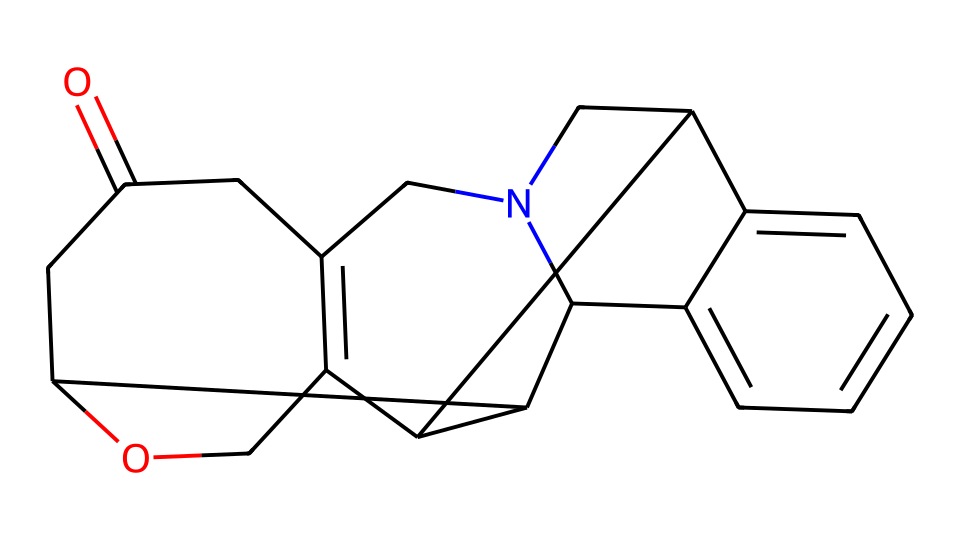What is the molecular formula of strychnine? To determine the molecular formula, we analyze the structure represented by the SMILES notation, counting the atoms of each element. The structure has 21 carbons, 24 hydrogens, 2 nitrogens, and 3 oxygens. Therefore, the molecular formula is C21H24N2O3.
Answer: C21H24N2O3 How many rings are present in the structure of strychnine? By carefully examining the SMILES notation, we can see that it contains two fused ring systems and one additional ring. Counting these, we find that there are three rings in total.
Answer: 3 What type of chemical structure does strychnine belong to? The presence of nitrogen atoms in its structure indicates that strychnine belongs to the class of compounds known as alkaloids, which are characterized by their nitrogen-containing structures and psychoactive properties.
Answer: alkaloid What is the potential effect of strychnine on wildlife populations? Strychnine is known to be a highly toxic compound, particularly affecting the central nervous system. Its acute toxicity can lead to muscle convulsions and death in wildlife, significantly impacting population health.
Answer: toxicity Which elements are present in the strychnine structure? Analyzing the SMILES notation, we identify the presence of carbon (C), hydrogen (H), nitrogen (N), and oxygen (O) atoms. These are the main elements that constitute the molecular structure of strychnine.
Answer: carbon, hydrogen, nitrogen, oxygen What functional groups can be identified in strychnine's structure? By examining the molecular structure, we can identify multiple functional groups, including a ketone (O=C) and heterocyclic rings containing nitrogen that characterize many alkaloids, aiding in defining its properties.
Answer: ketone, nitrogen-containing rings 